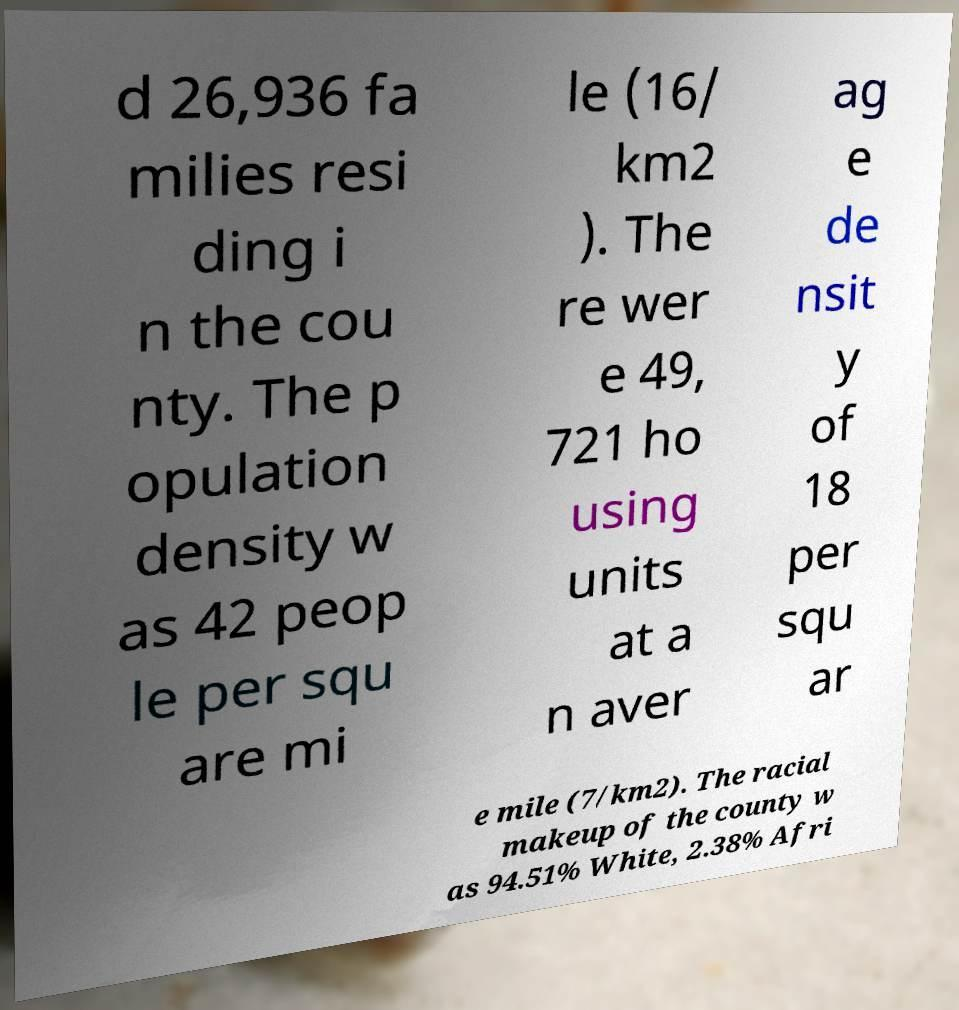For documentation purposes, I need the text within this image transcribed. Could you provide that? d 26,936 fa milies resi ding i n the cou nty. The p opulation density w as 42 peop le per squ are mi le (16/ km2 ). The re wer e 49, 721 ho using units at a n aver ag e de nsit y of 18 per squ ar e mile (7/km2). The racial makeup of the county w as 94.51% White, 2.38% Afri 